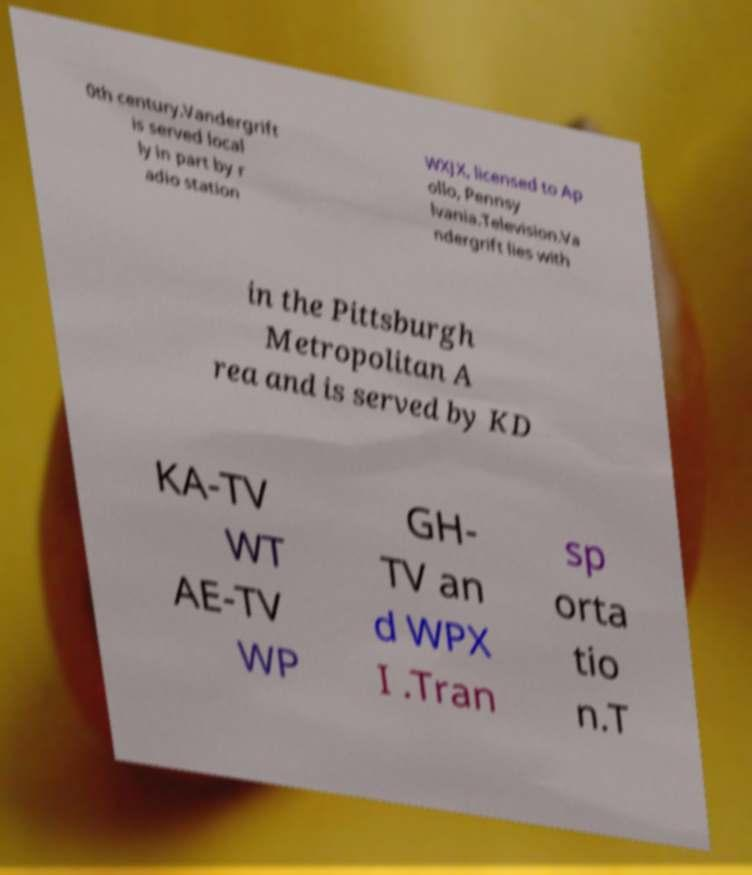Please read and relay the text visible in this image. What does it say? 0th century.Vandergrift is served local ly in part by r adio station WXJX, licensed to Ap ollo, Pennsy lvania.Television.Va ndergrift lies with in the Pittsburgh Metropolitan A rea and is served by KD KA-TV WT AE-TV WP GH- TV an d WPX I .Tran sp orta tio n.T 